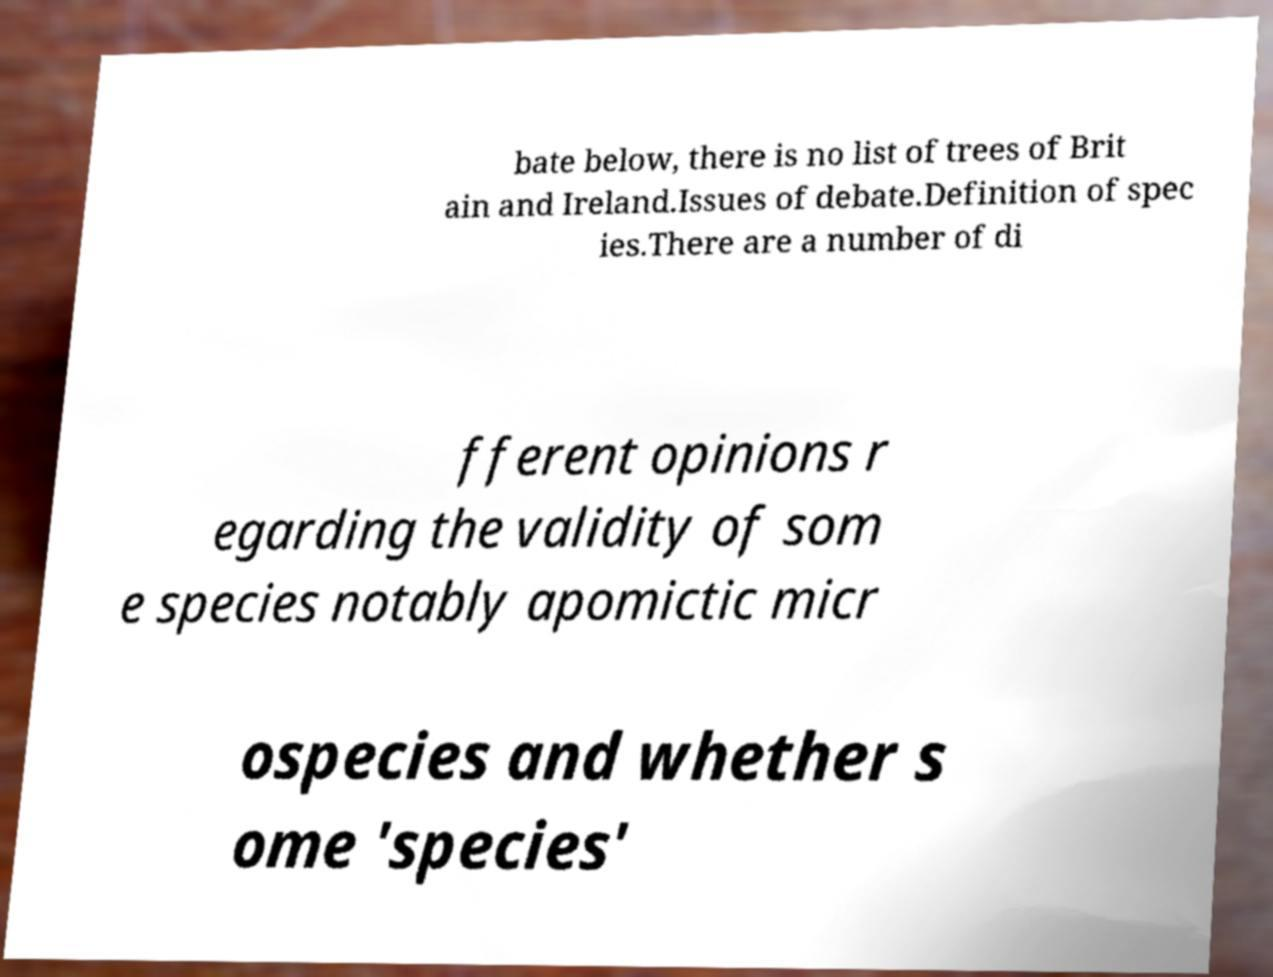Please identify and transcribe the text found in this image. bate below, there is no list of trees of Brit ain and Ireland.Issues of debate.Definition of spec ies.There are a number of di fferent opinions r egarding the validity of som e species notably apomictic micr ospecies and whether s ome 'species' 